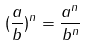Convert formula to latex. <formula><loc_0><loc_0><loc_500><loc_500>( \frac { a } { b } ) ^ { n } = \frac { a ^ { n } } { b ^ { n } }</formula> 